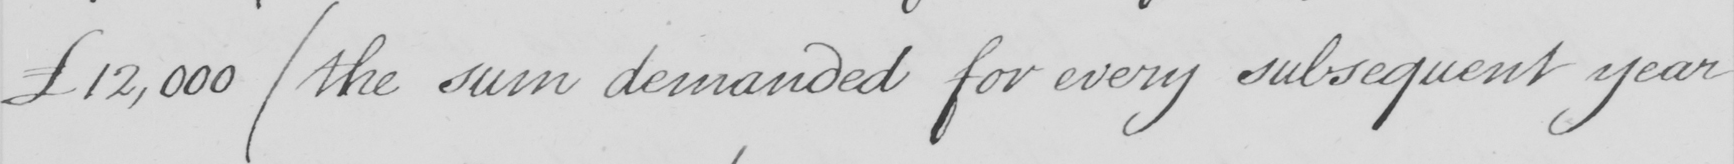Transcribe the text shown in this historical manuscript line. £12,000  ( the sum demanded for every subsequent year 